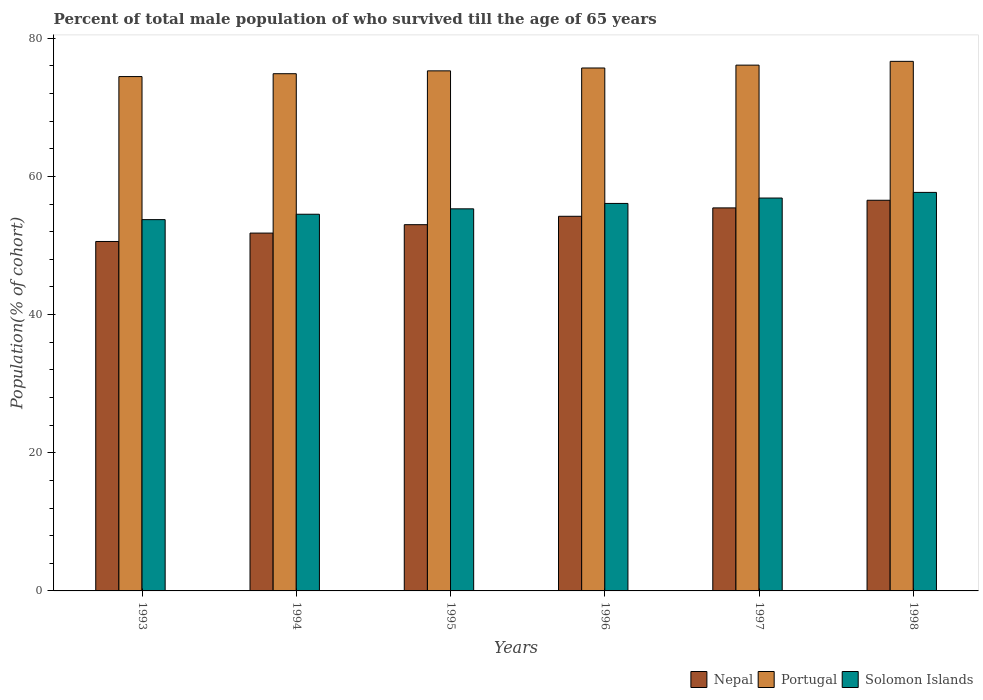How many groups of bars are there?
Keep it short and to the point. 6. How many bars are there on the 6th tick from the left?
Give a very brief answer. 3. In how many cases, is the number of bars for a given year not equal to the number of legend labels?
Give a very brief answer. 0. What is the percentage of total male population who survived till the age of 65 years in Portugal in 1997?
Give a very brief answer. 76.11. Across all years, what is the maximum percentage of total male population who survived till the age of 65 years in Portugal?
Provide a short and direct response. 76.66. Across all years, what is the minimum percentage of total male population who survived till the age of 65 years in Portugal?
Provide a short and direct response. 74.46. What is the total percentage of total male population who survived till the age of 65 years in Portugal in the graph?
Offer a very short reply. 453.09. What is the difference between the percentage of total male population who survived till the age of 65 years in Solomon Islands in 1993 and that in 1998?
Offer a terse response. -3.94. What is the difference between the percentage of total male population who survived till the age of 65 years in Nepal in 1996 and the percentage of total male population who survived till the age of 65 years in Solomon Islands in 1995?
Keep it short and to the point. -1.08. What is the average percentage of total male population who survived till the age of 65 years in Solomon Islands per year?
Your answer should be very brief. 55.71. In the year 1994, what is the difference between the percentage of total male population who survived till the age of 65 years in Solomon Islands and percentage of total male population who survived till the age of 65 years in Nepal?
Give a very brief answer. 2.73. What is the ratio of the percentage of total male population who survived till the age of 65 years in Nepal in 1994 to that in 1996?
Provide a succinct answer. 0.96. Is the percentage of total male population who survived till the age of 65 years in Solomon Islands in 1994 less than that in 1998?
Offer a terse response. Yes. Is the difference between the percentage of total male population who survived till the age of 65 years in Solomon Islands in 1995 and 1996 greater than the difference between the percentage of total male population who survived till the age of 65 years in Nepal in 1995 and 1996?
Offer a very short reply. Yes. What is the difference between the highest and the second highest percentage of total male population who survived till the age of 65 years in Nepal?
Your answer should be very brief. 1.11. What is the difference between the highest and the lowest percentage of total male population who survived till the age of 65 years in Nepal?
Give a very brief answer. 5.97. Is the sum of the percentage of total male population who survived till the age of 65 years in Nepal in 1993 and 1997 greater than the maximum percentage of total male population who survived till the age of 65 years in Portugal across all years?
Your response must be concise. Yes. What does the 3rd bar from the left in 1993 represents?
Your response must be concise. Solomon Islands. What does the 1st bar from the right in 1996 represents?
Make the answer very short. Solomon Islands. How many bars are there?
Your response must be concise. 18. Are the values on the major ticks of Y-axis written in scientific E-notation?
Your answer should be compact. No. Does the graph contain any zero values?
Keep it short and to the point. No. Does the graph contain grids?
Provide a succinct answer. No. How many legend labels are there?
Your answer should be compact. 3. What is the title of the graph?
Provide a succinct answer. Percent of total male population of who survived till the age of 65 years. Does "Madagascar" appear as one of the legend labels in the graph?
Your answer should be compact. No. What is the label or title of the X-axis?
Your answer should be compact. Years. What is the label or title of the Y-axis?
Give a very brief answer. Population(% of cohort). What is the Population(% of cohort) of Nepal in 1993?
Your response must be concise. 50.59. What is the Population(% of cohort) of Portugal in 1993?
Your answer should be compact. 74.46. What is the Population(% of cohort) of Solomon Islands in 1993?
Offer a terse response. 53.75. What is the Population(% of cohort) of Nepal in 1994?
Keep it short and to the point. 51.8. What is the Population(% of cohort) of Portugal in 1994?
Give a very brief answer. 74.87. What is the Population(% of cohort) of Solomon Islands in 1994?
Give a very brief answer. 54.53. What is the Population(% of cohort) of Nepal in 1995?
Keep it short and to the point. 53.02. What is the Population(% of cohort) in Portugal in 1995?
Keep it short and to the point. 75.29. What is the Population(% of cohort) in Solomon Islands in 1995?
Provide a short and direct response. 55.31. What is the Population(% of cohort) in Nepal in 1996?
Your answer should be very brief. 54.23. What is the Population(% of cohort) in Portugal in 1996?
Provide a short and direct response. 75.7. What is the Population(% of cohort) in Solomon Islands in 1996?
Offer a terse response. 56.09. What is the Population(% of cohort) of Nepal in 1997?
Ensure brevity in your answer.  55.45. What is the Population(% of cohort) of Portugal in 1997?
Your answer should be very brief. 76.11. What is the Population(% of cohort) of Solomon Islands in 1997?
Your answer should be very brief. 56.87. What is the Population(% of cohort) in Nepal in 1998?
Offer a very short reply. 56.55. What is the Population(% of cohort) of Portugal in 1998?
Offer a very short reply. 76.66. What is the Population(% of cohort) in Solomon Islands in 1998?
Your answer should be very brief. 57.69. Across all years, what is the maximum Population(% of cohort) of Nepal?
Make the answer very short. 56.55. Across all years, what is the maximum Population(% of cohort) of Portugal?
Your response must be concise. 76.66. Across all years, what is the maximum Population(% of cohort) of Solomon Islands?
Your response must be concise. 57.69. Across all years, what is the minimum Population(% of cohort) of Nepal?
Keep it short and to the point. 50.59. Across all years, what is the minimum Population(% of cohort) in Portugal?
Your answer should be compact. 74.46. Across all years, what is the minimum Population(% of cohort) in Solomon Islands?
Keep it short and to the point. 53.75. What is the total Population(% of cohort) of Nepal in the graph?
Keep it short and to the point. 321.64. What is the total Population(% of cohort) in Portugal in the graph?
Your answer should be compact. 453.09. What is the total Population(% of cohort) of Solomon Islands in the graph?
Provide a succinct answer. 334.25. What is the difference between the Population(% of cohort) of Nepal in 1993 and that in 1994?
Give a very brief answer. -1.22. What is the difference between the Population(% of cohort) in Portugal in 1993 and that in 1994?
Ensure brevity in your answer.  -0.41. What is the difference between the Population(% of cohort) of Solomon Islands in 1993 and that in 1994?
Your answer should be very brief. -0.78. What is the difference between the Population(% of cohort) of Nepal in 1993 and that in 1995?
Your answer should be compact. -2.43. What is the difference between the Population(% of cohort) of Portugal in 1993 and that in 1995?
Your response must be concise. -0.83. What is the difference between the Population(% of cohort) in Solomon Islands in 1993 and that in 1995?
Provide a succinct answer. -1.56. What is the difference between the Population(% of cohort) in Nepal in 1993 and that in 1996?
Ensure brevity in your answer.  -3.65. What is the difference between the Population(% of cohort) in Portugal in 1993 and that in 1996?
Give a very brief answer. -1.24. What is the difference between the Population(% of cohort) in Solomon Islands in 1993 and that in 1996?
Your answer should be very brief. -2.35. What is the difference between the Population(% of cohort) of Nepal in 1993 and that in 1997?
Your answer should be very brief. -4.86. What is the difference between the Population(% of cohort) in Portugal in 1993 and that in 1997?
Your answer should be compact. -1.66. What is the difference between the Population(% of cohort) in Solomon Islands in 1993 and that in 1997?
Offer a terse response. -3.13. What is the difference between the Population(% of cohort) of Nepal in 1993 and that in 1998?
Offer a terse response. -5.97. What is the difference between the Population(% of cohort) of Portugal in 1993 and that in 1998?
Your answer should be compact. -2.2. What is the difference between the Population(% of cohort) of Solomon Islands in 1993 and that in 1998?
Offer a terse response. -3.94. What is the difference between the Population(% of cohort) in Nepal in 1994 and that in 1995?
Give a very brief answer. -1.22. What is the difference between the Population(% of cohort) in Portugal in 1994 and that in 1995?
Offer a very short reply. -0.41. What is the difference between the Population(% of cohort) in Solomon Islands in 1994 and that in 1995?
Make the answer very short. -0.78. What is the difference between the Population(% of cohort) of Nepal in 1994 and that in 1996?
Offer a very short reply. -2.43. What is the difference between the Population(% of cohort) in Portugal in 1994 and that in 1996?
Your answer should be compact. -0.83. What is the difference between the Population(% of cohort) in Solomon Islands in 1994 and that in 1996?
Offer a very short reply. -1.56. What is the difference between the Population(% of cohort) of Nepal in 1994 and that in 1997?
Provide a succinct answer. -3.65. What is the difference between the Population(% of cohort) of Portugal in 1994 and that in 1997?
Provide a short and direct response. -1.24. What is the difference between the Population(% of cohort) of Solomon Islands in 1994 and that in 1997?
Offer a very short reply. -2.35. What is the difference between the Population(% of cohort) of Nepal in 1994 and that in 1998?
Offer a very short reply. -4.75. What is the difference between the Population(% of cohort) of Portugal in 1994 and that in 1998?
Offer a terse response. -1.79. What is the difference between the Population(% of cohort) in Solomon Islands in 1994 and that in 1998?
Your answer should be compact. -3.16. What is the difference between the Population(% of cohort) of Nepal in 1995 and that in 1996?
Offer a terse response. -1.22. What is the difference between the Population(% of cohort) of Portugal in 1995 and that in 1996?
Your response must be concise. -0.41. What is the difference between the Population(% of cohort) in Solomon Islands in 1995 and that in 1996?
Keep it short and to the point. -0.78. What is the difference between the Population(% of cohort) in Nepal in 1995 and that in 1997?
Give a very brief answer. -2.43. What is the difference between the Population(% of cohort) in Portugal in 1995 and that in 1997?
Make the answer very short. -0.83. What is the difference between the Population(% of cohort) in Solomon Islands in 1995 and that in 1997?
Offer a terse response. -1.56. What is the difference between the Population(% of cohort) in Nepal in 1995 and that in 1998?
Your answer should be very brief. -3.54. What is the difference between the Population(% of cohort) in Portugal in 1995 and that in 1998?
Ensure brevity in your answer.  -1.37. What is the difference between the Population(% of cohort) of Solomon Islands in 1995 and that in 1998?
Your response must be concise. -2.38. What is the difference between the Population(% of cohort) of Nepal in 1996 and that in 1997?
Your response must be concise. -1.22. What is the difference between the Population(% of cohort) of Portugal in 1996 and that in 1997?
Make the answer very short. -0.41. What is the difference between the Population(% of cohort) of Solomon Islands in 1996 and that in 1997?
Offer a terse response. -0.78. What is the difference between the Population(% of cohort) of Nepal in 1996 and that in 1998?
Ensure brevity in your answer.  -2.32. What is the difference between the Population(% of cohort) of Portugal in 1996 and that in 1998?
Make the answer very short. -0.96. What is the difference between the Population(% of cohort) in Solomon Islands in 1996 and that in 1998?
Your response must be concise. -1.6. What is the difference between the Population(% of cohort) of Nepal in 1997 and that in 1998?
Offer a very short reply. -1.11. What is the difference between the Population(% of cohort) in Portugal in 1997 and that in 1998?
Provide a succinct answer. -0.55. What is the difference between the Population(% of cohort) of Solomon Islands in 1997 and that in 1998?
Your answer should be compact. -0.82. What is the difference between the Population(% of cohort) in Nepal in 1993 and the Population(% of cohort) in Portugal in 1994?
Offer a terse response. -24.29. What is the difference between the Population(% of cohort) in Nepal in 1993 and the Population(% of cohort) in Solomon Islands in 1994?
Make the answer very short. -3.94. What is the difference between the Population(% of cohort) of Portugal in 1993 and the Population(% of cohort) of Solomon Islands in 1994?
Ensure brevity in your answer.  19.93. What is the difference between the Population(% of cohort) in Nepal in 1993 and the Population(% of cohort) in Portugal in 1995?
Your answer should be compact. -24.7. What is the difference between the Population(% of cohort) in Nepal in 1993 and the Population(% of cohort) in Solomon Islands in 1995?
Make the answer very short. -4.73. What is the difference between the Population(% of cohort) of Portugal in 1993 and the Population(% of cohort) of Solomon Islands in 1995?
Give a very brief answer. 19.15. What is the difference between the Population(% of cohort) in Nepal in 1993 and the Population(% of cohort) in Portugal in 1996?
Your answer should be compact. -25.11. What is the difference between the Population(% of cohort) in Nepal in 1993 and the Population(% of cohort) in Solomon Islands in 1996?
Make the answer very short. -5.51. What is the difference between the Population(% of cohort) in Portugal in 1993 and the Population(% of cohort) in Solomon Islands in 1996?
Give a very brief answer. 18.37. What is the difference between the Population(% of cohort) of Nepal in 1993 and the Population(% of cohort) of Portugal in 1997?
Ensure brevity in your answer.  -25.53. What is the difference between the Population(% of cohort) of Nepal in 1993 and the Population(% of cohort) of Solomon Islands in 1997?
Your answer should be very brief. -6.29. What is the difference between the Population(% of cohort) of Portugal in 1993 and the Population(% of cohort) of Solomon Islands in 1997?
Make the answer very short. 17.58. What is the difference between the Population(% of cohort) of Nepal in 1993 and the Population(% of cohort) of Portugal in 1998?
Keep it short and to the point. -26.08. What is the difference between the Population(% of cohort) of Nepal in 1993 and the Population(% of cohort) of Solomon Islands in 1998?
Your answer should be very brief. -7.11. What is the difference between the Population(% of cohort) of Portugal in 1993 and the Population(% of cohort) of Solomon Islands in 1998?
Provide a short and direct response. 16.77. What is the difference between the Population(% of cohort) in Nepal in 1994 and the Population(% of cohort) in Portugal in 1995?
Make the answer very short. -23.48. What is the difference between the Population(% of cohort) of Nepal in 1994 and the Population(% of cohort) of Solomon Islands in 1995?
Ensure brevity in your answer.  -3.51. What is the difference between the Population(% of cohort) of Portugal in 1994 and the Population(% of cohort) of Solomon Islands in 1995?
Your answer should be compact. 19.56. What is the difference between the Population(% of cohort) of Nepal in 1994 and the Population(% of cohort) of Portugal in 1996?
Your answer should be very brief. -23.9. What is the difference between the Population(% of cohort) of Nepal in 1994 and the Population(% of cohort) of Solomon Islands in 1996?
Your answer should be very brief. -4.29. What is the difference between the Population(% of cohort) in Portugal in 1994 and the Population(% of cohort) in Solomon Islands in 1996?
Your response must be concise. 18.78. What is the difference between the Population(% of cohort) in Nepal in 1994 and the Population(% of cohort) in Portugal in 1997?
Your response must be concise. -24.31. What is the difference between the Population(% of cohort) in Nepal in 1994 and the Population(% of cohort) in Solomon Islands in 1997?
Your response must be concise. -5.07. What is the difference between the Population(% of cohort) of Portugal in 1994 and the Population(% of cohort) of Solomon Islands in 1997?
Your response must be concise. 18. What is the difference between the Population(% of cohort) of Nepal in 1994 and the Population(% of cohort) of Portugal in 1998?
Ensure brevity in your answer.  -24.86. What is the difference between the Population(% of cohort) in Nepal in 1994 and the Population(% of cohort) in Solomon Islands in 1998?
Make the answer very short. -5.89. What is the difference between the Population(% of cohort) of Portugal in 1994 and the Population(% of cohort) of Solomon Islands in 1998?
Your response must be concise. 17.18. What is the difference between the Population(% of cohort) of Nepal in 1995 and the Population(% of cohort) of Portugal in 1996?
Ensure brevity in your answer.  -22.68. What is the difference between the Population(% of cohort) in Nepal in 1995 and the Population(% of cohort) in Solomon Islands in 1996?
Provide a short and direct response. -3.08. What is the difference between the Population(% of cohort) in Portugal in 1995 and the Population(% of cohort) in Solomon Islands in 1996?
Provide a short and direct response. 19.19. What is the difference between the Population(% of cohort) in Nepal in 1995 and the Population(% of cohort) in Portugal in 1997?
Offer a terse response. -23.1. What is the difference between the Population(% of cohort) of Nepal in 1995 and the Population(% of cohort) of Solomon Islands in 1997?
Ensure brevity in your answer.  -3.86. What is the difference between the Population(% of cohort) in Portugal in 1995 and the Population(% of cohort) in Solomon Islands in 1997?
Offer a very short reply. 18.41. What is the difference between the Population(% of cohort) in Nepal in 1995 and the Population(% of cohort) in Portugal in 1998?
Your response must be concise. -23.64. What is the difference between the Population(% of cohort) in Nepal in 1995 and the Population(% of cohort) in Solomon Islands in 1998?
Offer a very short reply. -4.67. What is the difference between the Population(% of cohort) in Portugal in 1995 and the Population(% of cohort) in Solomon Islands in 1998?
Keep it short and to the point. 17.59. What is the difference between the Population(% of cohort) of Nepal in 1996 and the Population(% of cohort) of Portugal in 1997?
Provide a short and direct response. -21.88. What is the difference between the Population(% of cohort) of Nepal in 1996 and the Population(% of cohort) of Solomon Islands in 1997?
Ensure brevity in your answer.  -2.64. What is the difference between the Population(% of cohort) of Portugal in 1996 and the Population(% of cohort) of Solomon Islands in 1997?
Keep it short and to the point. 18.83. What is the difference between the Population(% of cohort) of Nepal in 1996 and the Population(% of cohort) of Portugal in 1998?
Your answer should be compact. -22.43. What is the difference between the Population(% of cohort) in Nepal in 1996 and the Population(% of cohort) in Solomon Islands in 1998?
Provide a short and direct response. -3.46. What is the difference between the Population(% of cohort) of Portugal in 1996 and the Population(% of cohort) of Solomon Islands in 1998?
Your response must be concise. 18.01. What is the difference between the Population(% of cohort) in Nepal in 1997 and the Population(% of cohort) in Portugal in 1998?
Keep it short and to the point. -21.21. What is the difference between the Population(% of cohort) of Nepal in 1997 and the Population(% of cohort) of Solomon Islands in 1998?
Make the answer very short. -2.24. What is the difference between the Population(% of cohort) in Portugal in 1997 and the Population(% of cohort) in Solomon Islands in 1998?
Your answer should be very brief. 18.42. What is the average Population(% of cohort) in Nepal per year?
Give a very brief answer. 53.61. What is the average Population(% of cohort) in Portugal per year?
Keep it short and to the point. 75.52. What is the average Population(% of cohort) of Solomon Islands per year?
Give a very brief answer. 55.71. In the year 1993, what is the difference between the Population(% of cohort) in Nepal and Population(% of cohort) in Portugal?
Keep it short and to the point. -23.87. In the year 1993, what is the difference between the Population(% of cohort) of Nepal and Population(% of cohort) of Solomon Islands?
Offer a terse response. -3.16. In the year 1993, what is the difference between the Population(% of cohort) in Portugal and Population(% of cohort) in Solomon Islands?
Your response must be concise. 20.71. In the year 1994, what is the difference between the Population(% of cohort) in Nepal and Population(% of cohort) in Portugal?
Give a very brief answer. -23.07. In the year 1994, what is the difference between the Population(% of cohort) of Nepal and Population(% of cohort) of Solomon Islands?
Offer a terse response. -2.73. In the year 1994, what is the difference between the Population(% of cohort) of Portugal and Population(% of cohort) of Solomon Islands?
Your response must be concise. 20.34. In the year 1995, what is the difference between the Population(% of cohort) of Nepal and Population(% of cohort) of Portugal?
Offer a very short reply. -22.27. In the year 1995, what is the difference between the Population(% of cohort) in Nepal and Population(% of cohort) in Solomon Islands?
Offer a very short reply. -2.29. In the year 1995, what is the difference between the Population(% of cohort) in Portugal and Population(% of cohort) in Solomon Islands?
Ensure brevity in your answer.  19.97. In the year 1996, what is the difference between the Population(% of cohort) of Nepal and Population(% of cohort) of Portugal?
Ensure brevity in your answer.  -21.47. In the year 1996, what is the difference between the Population(% of cohort) in Nepal and Population(% of cohort) in Solomon Islands?
Your answer should be compact. -1.86. In the year 1996, what is the difference between the Population(% of cohort) of Portugal and Population(% of cohort) of Solomon Islands?
Your response must be concise. 19.61. In the year 1997, what is the difference between the Population(% of cohort) of Nepal and Population(% of cohort) of Portugal?
Your response must be concise. -20.67. In the year 1997, what is the difference between the Population(% of cohort) in Nepal and Population(% of cohort) in Solomon Islands?
Give a very brief answer. -1.43. In the year 1997, what is the difference between the Population(% of cohort) in Portugal and Population(% of cohort) in Solomon Islands?
Your answer should be very brief. 19.24. In the year 1998, what is the difference between the Population(% of cohort) in Nepal and Population(% of cohort) in Portugal?
Your answer should be very brief. -20.11. In the year 1998, what is the difference between the Population(% of cohort) of Nepal and Population(% of cohort) of Solomon Islands?
Make the answer very short. -1.14. In the year 1998, what is the difference between the Population(% of cohort) of Portugal and Population(% of cohort) of Solomon Islands?
Offer a terse response. 18.97. What is the ratio of the Population(% of cohort) of Nepal in 1993 to that in 1994?
Provide a short and direct response. 0.98. What is the ratio of the Population(% of cohort) in Solomon Islands in 1993 to that in 1994?
Ensure brevity in your answer.  0.99. What is the ratio of the Population(% of cohort) of Nepal in 1993 to that in 1995?
Your answer should be compact. 0.95. What is the ratio of the Population(% of cohort) of Portugal in 1993 to that in 1995?
Your answer should be compact. 0.99. What is the ratio of the Population(% of cohort) of Solomon Islands in 1993 to that in 1995?
Offer a terse response. 0.97. What is the ratio of the Population(% of cohort) in Nepal in 1993 to that in 1996?
Keep it short and to the point. 0.93. What is the ratio of the Population(% of cohort) of Portugal in 1993 to that in 1996?
Offer a very short reply. 0.98. What is the ratio of the Population(% of cohort) in Solomon Islands in 1993 to that in 1996?
Your answer should be compact. 0.96. What is the ratio of the Population(% of cohort) of Nepal in 1993 to that in 1997?
Provide a succinct answer. 0.91. What is the ratio of the Population(% of cohort) in Portugal in 1993 to that in 1997?
Keep it short and to the point. 0.98. What is the ratio of the Population(% of cohort) in Solomon Islands in 1993 to that in 1997?
Keep it short and to the point. 0.94. What is the ratio of the Population(% of cohort) of Nepal in 1993 to that in 1998?
Offer a very short reply. 0.89. What is the ratio of the Population(% of cohort) in Portugal in 1993 to that in 1998?
Offer a very short reply. 0.97. What is the ratio of the Population(% of cohort) of Solomon Islands in 1993 to that in 1998?
Your response must be concise. 0.93. What is the ratio of the Population(% of cohort) of Nepal in 1994 to that in 1995?
Provide a succinct answer. 0.98. What is the ratio of the Population(% of cohort) of Portugal in 1994 to that in 1995?
Your response must be concise. 0.99. What is the ratio of the Population(% of cohort) of Solomon Islands in 1994 to that in 1995?
Offer a very short reply. 0.99. What is the ratio of the Population(% of cohort) in Nepal in 1994 to that in 1996?
Your answer should be very brief. 0.96. What is the ratio of the Population(% of cohort) in Solomon Islands in 1994 to that in 1996?
Ensure brevity in your answer.  0.97. What is the ratio of the Population(% of cohort) in Nepal in 1994 to that in 1997?
Offer a very short reply. 0.93. What is the ratio of the Population(% of cohort) of Portugal in 1994 to that in 1997?
Provide a short and direct response. 0.98. What is the ratio of the Population(% of cohort) of Solomon Islands in 1994 to that in 1997?
Your answer should be compact. 0.96. What is the ratio of the Population(% of cohort) in Nepal in 1994 to that in 1998?
Ensure brevity in your answer.  0.92. What is the ratio of the Population(% of cohort) of Portugal in 1994 to that in 1998?
Your answer should be very brief. 0.98. What is the ratio of the Population(% of cohort) in Solomon Islands in 1994 to that in 1998?
Your answer should be compact. 0.95. What is the ratio of the Population(% of cohort) of Nepal in 1995 to that in 1996?
Provide a succinct answer. 0.98. What is the ratio of the Population(% of cohort) of Portugal in 1995 to that in 1996?
Make the answer very short. 0.99. What is the ratio of the Population(% of cohort) in Solomon Islands in 1995 to that in 1996?
Offer a terse response. 0.99. What is the ratio of the Population(% of cohort) in Nepal in 1995 to that in 1997?
Keep it short and to the point. 0.96. What is the ratio of the Population(% of cohort) in Portugal in 1995 to that in 1997?
Offer a very short reply. 0.99. What is the ratio of the Population(% of cohort) of Solomon Islands in 1995 to that in 1997?
Offer a very short reply. 0.97. What is the ratio of the Population(% of cohort) in Nepal in 1995 to that in 1998?
Ensure brevity in your answer.  0.94. What is the ratio of the Population(% of cohort) of Portugal in 1995 to that in 1998?
Provide a short and direct response. 0.98. What is the ratio of the Population(% of cohort) in Solomon Islands in 1995 to that in 1998?
Keep it short and to the point. 0.96. What is the ratio of the Population(% of cohort) in Nepal in 1996 to that in 1997?
Offer a terse response. 0.98. What is the ratio of the Population(% of cohort) in Portugal in 1996 to that in 1997?
Offer a very short reply. 0.99. What is the ratio of the Population(% of cohort) of Solomon Islands in 1996 to that in 1997?
Your answer should be very brief. 0.99. What is the ratio of the Population(% of cohort) of Nepal in 1996 to that in 1998?
Your answer should be very brief. 0.96. What is the ratio of the Population(% of cohort) of Portugal in 1996 to that in 1998?
Provide a succinct answer. 0.99. What is the ratio of the Population(% of cohort) in Solomon Islands in 1996 to that in 1998?
Make the answer very short. 0.97. What is the ratio of the Population(% of cohort) of Nepal in 1997 to that in 1998?
Give a very brief answer. 0.98. What is the ratio of the Population(% of cohort) in Solomon Islands in 1997 to that in 1998?
Offer a very short reply. 0.99. What is the difference between the highest and the second highest Population(% of cohort) of Nepal?
Provide a succinct answer. 1.11. What is the difference between the highest and the second highest Population(% of cohort) of Portugal?
Your answer should be very brief. 0.55. What is the difference between the highest and the second highest Population(% of cohort) in Solomon Islands?
Your answer should be compact. 0.82. What is the difference between the highest and the lowest Population(% of cohort) of Nepal?
Provide a succinct answer. 5.97. What is the difference between the highest and the lowest Population(% of cohort) in Portugal?
Your response must be concise. 2.2. What is the difference between the highest and the lowest Population(% of cohort) of Solomon Islands?
Offer a terse response. 3.94. 